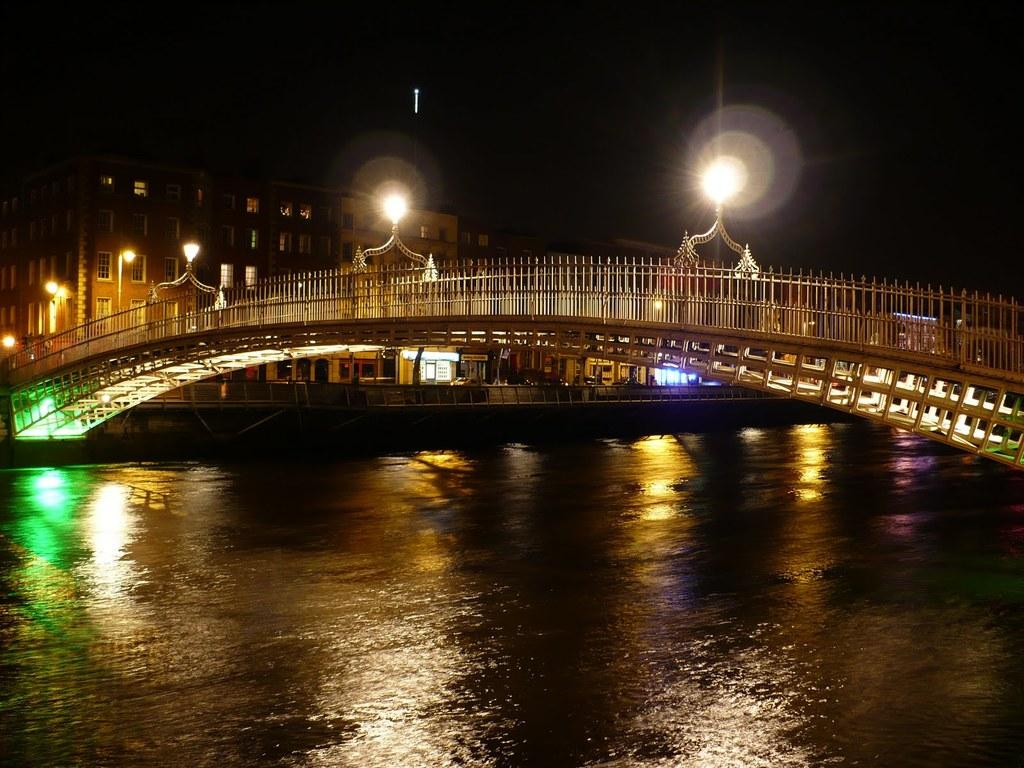What is the primary element in the image? There is water in the image. What structure is built over the water? There is a bridge over the water. Are there any features on the bridge? Yes, there are lightings on the bridge. What can be seen in the background of the image? There are buildings visible behind the bridge. What type of camp can be seen near the water in the image? There is no camp present in the image; it features water, a bridge, lightings, and buildings in the background. What memory is being triggered by the image? The image does not depict a specific memory, and it cannot trigger a memory for someone who has not seen it before. 